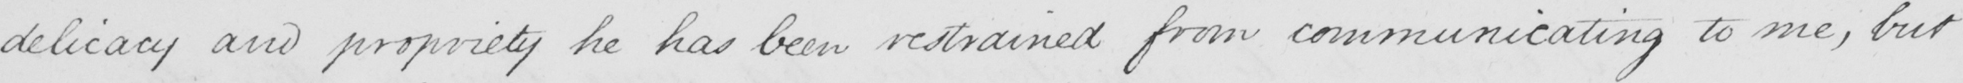What is written in this line of handwriting? delicacy and propriety he has been restrained from communicating to me , but 